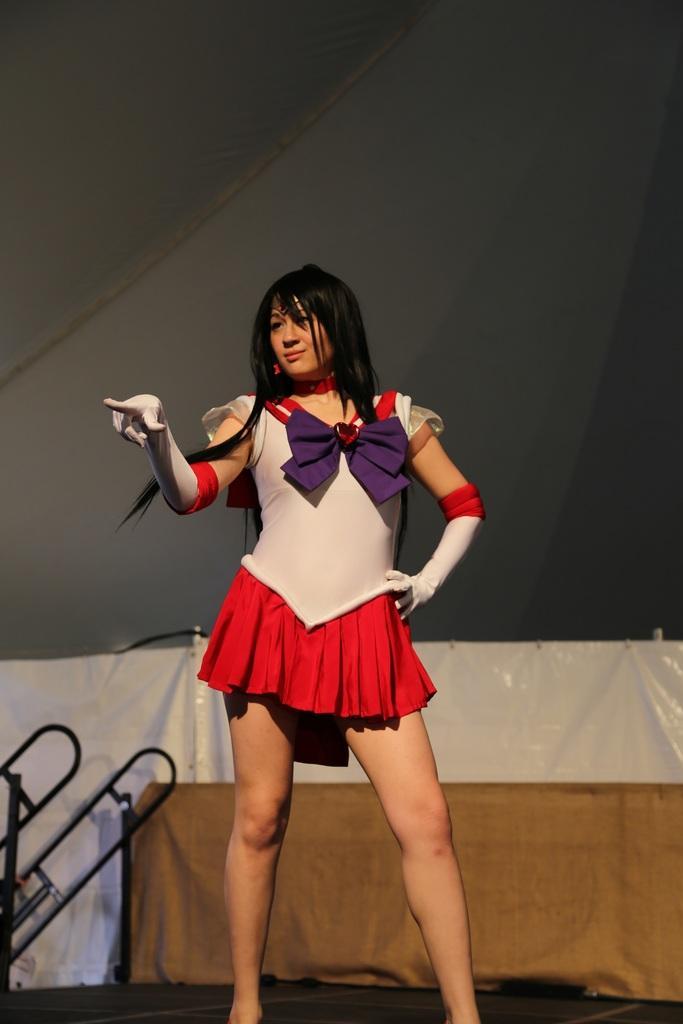Can you describe this image briefly? In this picture we can see a person on the path and behind the person there is a cloth and other things. 